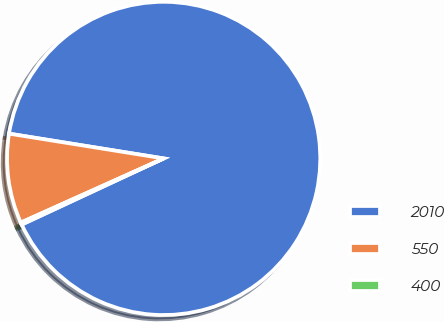Convert chart to OTSL. <chart><loc_0><loc_0><loc_500><loc_500><pie_chart><fcel>2010<fcel>550<fcel>400<nl><fcel>90.53%<fcel>9.25%<fcel>0.22%<nl></chart> 